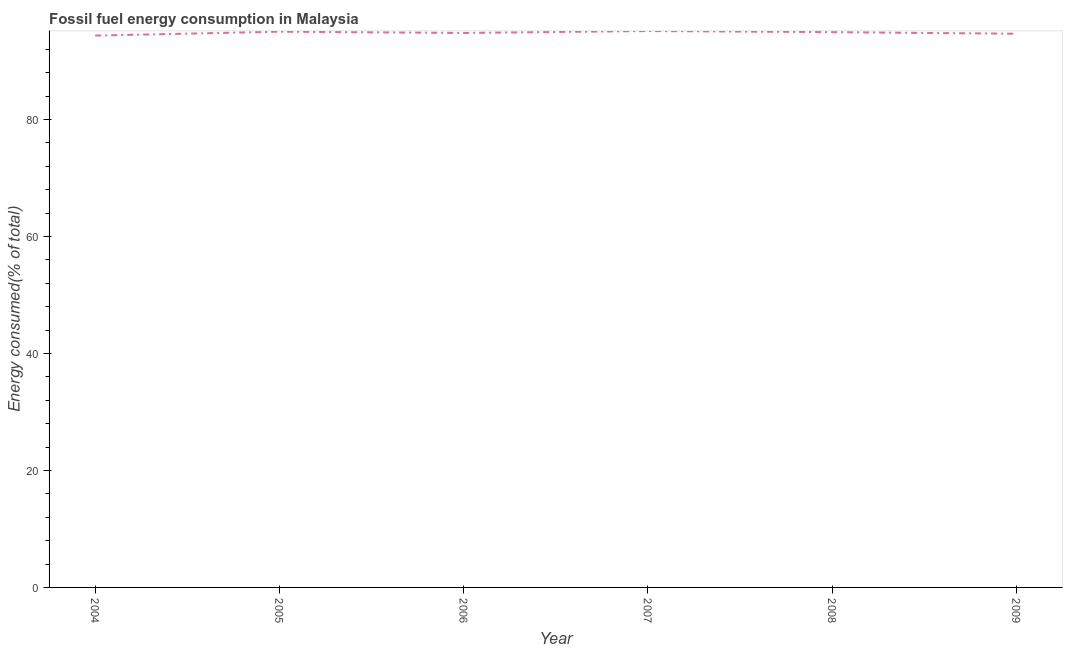What is the fossil fuel energy consumption in 2006?
Your answer should be very brief. 94.79. Across all years, what is the maximum fossil fuel energy consumption?
Your answer should be very brief. 95.12. Across all years, what is the minimum fossil fuel energy consumption?
Ensure brevity in your answer.  94.34. What is the sum of the fossil fuel energy consumption?
Offer a very short reply. 568.84. What is the difference between the fossil fuel energy consumption in 2007 and 2008?
Ensure brevity in your answer.  0.19. What is the average fossil fuel energy consumption per year?
Make the answer very short. 94.81. What is the median fossil fuel energy consumption?
Your response must be concise. 94.86. What is the ratio of the fossil fuel energy consumption in 2006 to that in 2007?
Give a very brief answer. 1. Is the fossil fuel energy consumption in 2004 less than that in 2007?
Provide a short and direct response. Yes. What is the difference between the highest and the second highest fossil fuel energy consumption?
Provide a succinct answer. 0.11. What is the difference between the highest and the lowest fossil fuel energy consumption?
Provide a short and direct response. 0.77. Does the graph contain any zero values?
Provide a succinct answer. No. What is the title of the graph?
Your answer should be very brief. Fossil fuel energy consumption in Malaysia. What is the label or title of the X-axis?
Provide a short and direct response. Year. What is the label or title of the Y-axis?
Your answer should be very brief. Energy consumed(% of total). What is the Energy consumed(% of total) of 2004?
Offer a terse response. 94.34. What is the Energy consumed(% of total) in 2005?
Provide a short and direct response. 95.01. What is the Energy consumed(% of total) in 2006?
Provide a succinct answer. 94.79. What is the Energy consumed(% of total) in 2007?
Your answer should be compact. 95.12. What is the Energy consumed(% of total) in 2008?
Give a very brief answer. 94.93. What is the Energy consumed(% of total) in 2009?
Provide a short and direct response. 94.65. What is the difference between the Energy consumed(% of total) in 2004 and 2005?
Your answer should be very brief. -0.66. What is the difference between the Energy consumed(% of total) in 2004 and 2006?
Offer a terse response. -0.45. What is the difference between the Energy consumed(% of total) in 2004 and 2007?
Your answer should be compact. -0.77. What is the difference between the Energy consumed(% of total) in 2004 and 2008?
Your answer should be very brief. -0.59. What is the difference between the Energy consumed(% of total) in 2004 and 2009?
Ensure brevity in your answer.  -0.31. What is the difference between the Energy consumed(% of total) in 2005 and 2006?
Your answer should be compact. 0.21. What is the difference between the Energy consumed(% of total) in 2005 and 2007?
Offer a very short reply. -0.11. What is the difference between the Energy consumed(% of total) in 2005 and 2008?
Provide a succinct answer. 0.07. What is the difference between the Energy consumed(% of total) in 2005 and 2009?
Offer a very short reply. 0.35. What is the difference between the Energy consumed(% of total) in 2006 and 2007?
Offer a very short reply. -0.33. What is the difference between the Energy consumed(% of total) in 2006 and 2008?
Ensure brevity in your answer.  -0.14. What is the difference between the Energy consumed(% of total) in 2006 and 2009?
Your response must be concise. 0.14. What is the difference between the Energy consumed(% of total) in 2007 and 2008?
Keep it short and to the point. 0.19. What is the difference between the Energy consumed(% of total) in 2007 and 2009?
Offer a very short reply. 0.46. What is the difference between the Energy consumed(% of total) in 2008 and 2009?
Your response must be concise. 0.28. What is the ratio of the Energy consumed(% of total) in 2004 to that in 2007?
Make the answer very short. 0.99. What is the ratio of the Energy consumed(% of total) in 2005 to that in 2007?
Your response must be concise. 1. What is the ratio of the Energy consumed(% of total) in 2006 to that in 2008?
Offer a very short reply. 1. What is the ratio of the Energy consumed(% of total) in 2006 to that in 2009?
Your answer should be compact. 1. What is the ratio of the Energy consumed(% of total) in 2007 to that in 2008?
Your answer should be very brief. 1. What is the ratio of the Energy consumed(% of total) in 2007 to that in 2009?
Offer a terse response. 1. 